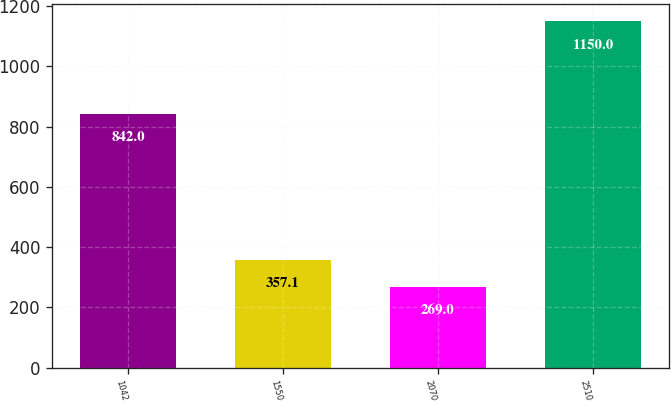<chart> <loc_0><loc_0><loc_500><loc_500><bar_chart><fcel>1042<fcel>1550<fcel>2070<fcel>2510<nl><fcel>842<fcel>357.1<fcel>269<fcel>1150<nl></chart> 